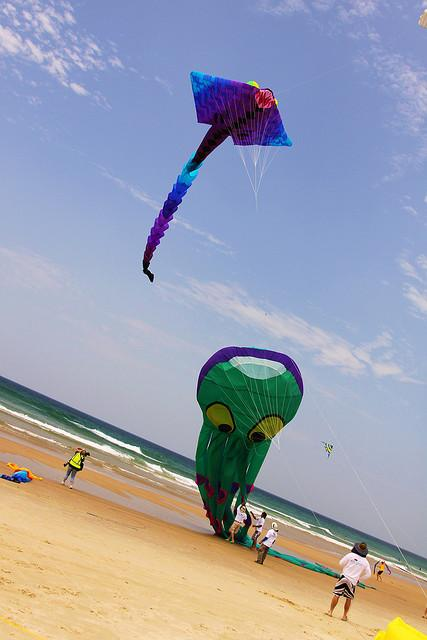How might the real version of the kite animal on top defend itself? tentacles 